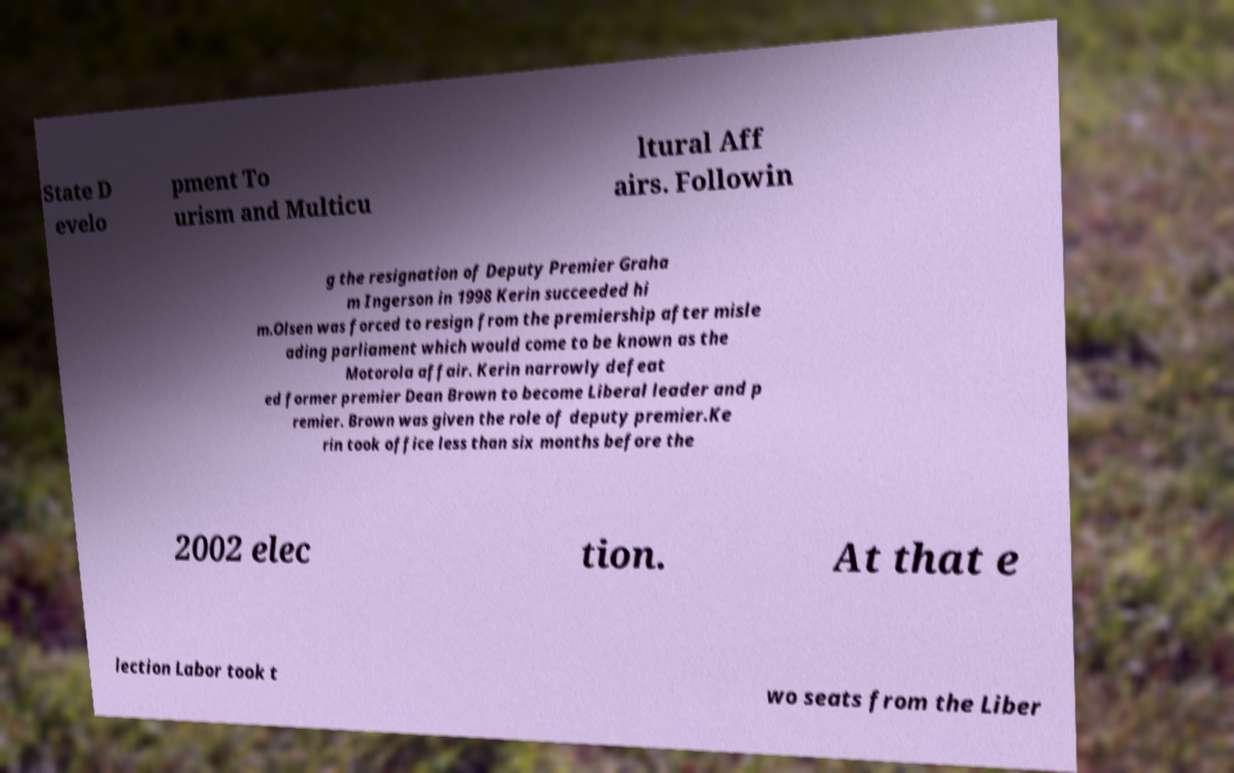Could you assist in decoding the text presented in this image and type it out clearly? State D evelo pment To urism and Multicu ltural Aff airs. Followin g the resignation of Deputy Premier Graha m Ingerson in 1998 Kerin succeeded hi m.Olsen was forced to resign from the premiership after misle ading parliament which would come to be known as the Motorola affair. Kerin narrowly defeat ed former premier Dean Brown to become Liberal leader and p remier. Brown was given the role of deputy premier.Ke rin took office less than six months before the 2002 elec tion. At that e lection Labor took t wo seats from the Liber 